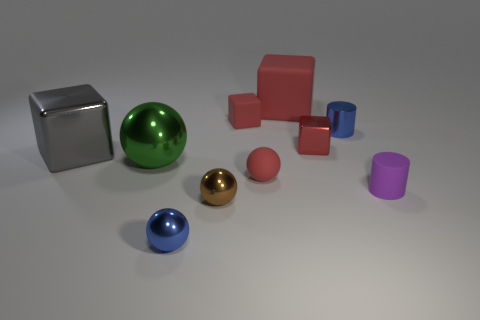There is a tiny rubber object that is the same color as the small matte cube; what is its shape?
Your response must be concise. Sphere. There is a metal thing that is the same color as the big rubber cube; what is its size?
Provide a short and direct response. Small. Is the number of red rubber blocks that are to the left of the small purple matte cylinder greater than the number of big green metal balls?
Offer a terse response. Yes. There is a tiny red thing that is made of the same material as the large gray thing; what shape is it?
Keep it short and to the point. Cube. Does the red metal object that is on the right side of the gray metal cube have the same size as the small red rubber ball?
Provide a succinct answer. Yes. There is a red matte thing that is in front of the object on the left side of the big green sphere; what is its shape?
Your response must be concise. Sphere. What size is the thing that is to the left of the large green metallic sphere that is left of the small rubber cube?
Your response must be concise. Large. What color is the cylinder that is behind the purple rubber cylinder?
Keep it short and to the point. Blue. What is the size of the green thing that is made of the same material as the gray cube?
Provide a succinct answer. Large. How many metal objects are the same shape as the purple matte thing?
Your response must be concise. 1. 